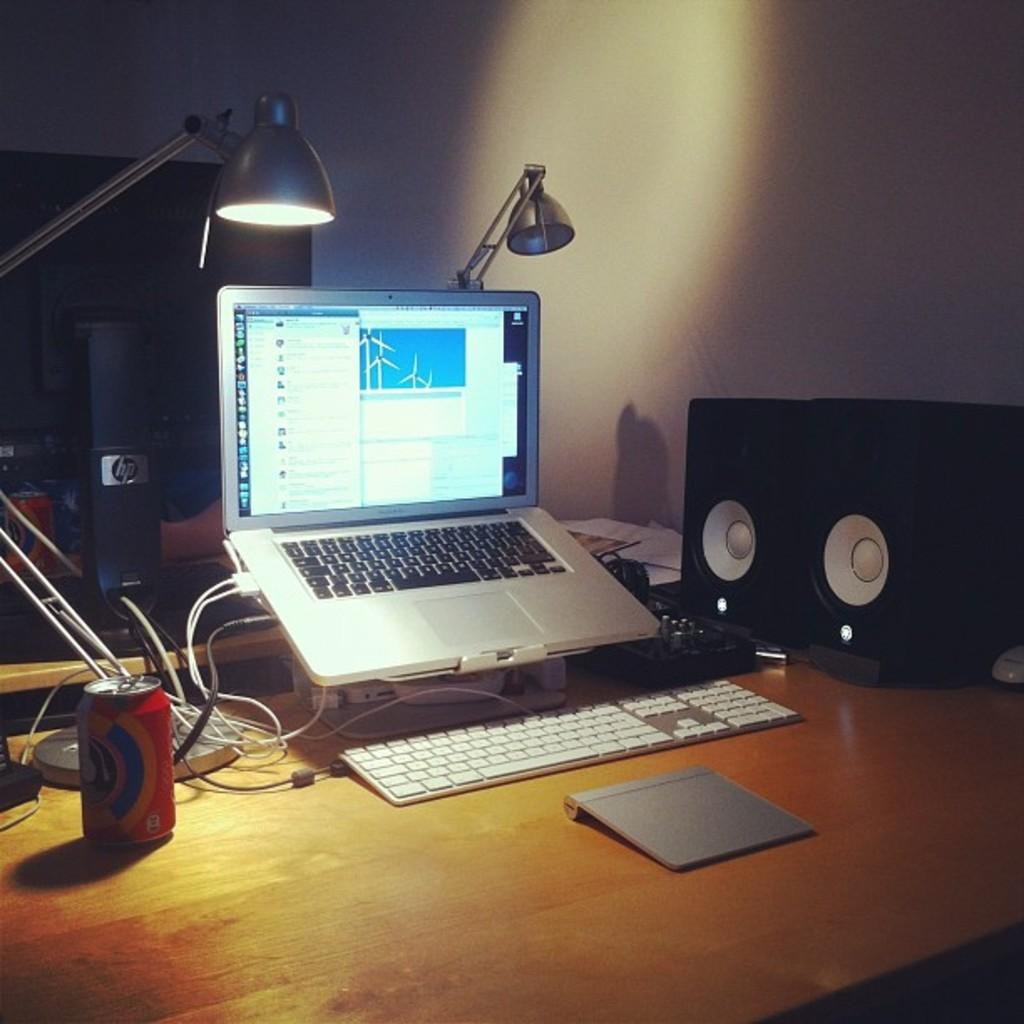What electronic device is visible in the image? There is a laptop in the image. What type of wires can be seen in the image? Cable wires are visible in the image. What is used for typing in the image? There is a keyboard in the image. What devices are used for audio output in the image? Speakers are present in the image. What type of container is in the image? There is a tin in the image. What is the source of illumination in the image? There is light in the image. Where are all these objects placed? All these objects are placed on a table. How many birds are sitting on the laptop in the image? There are no birds present in the image; it only features a laptop, cable wires, a keyboard, speakers, a tin, light, and a table. 